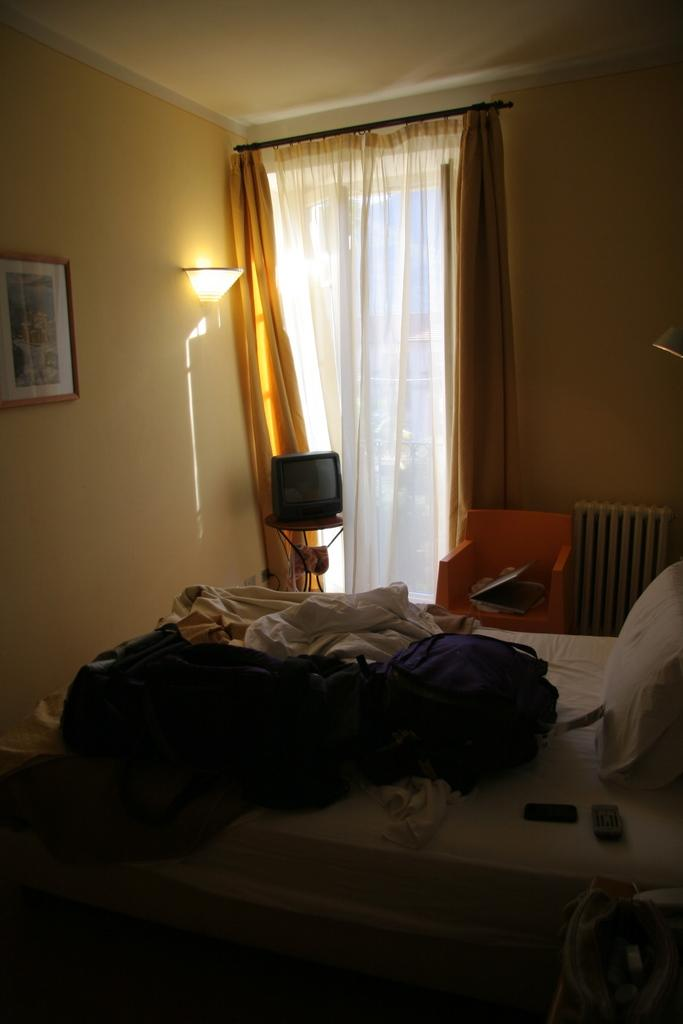What type of space is shown in the image? The image depicts an inside view of a room. What furniture is present in the room? There is a bed and a chair in the room. What electronic device is in the room? There is a television in the room. What window treatment is present in the room? There are curtains in the room. What lighting is present in the room? There are lights in the room. What decorative item is on the wall in the room? There is a frame on the wall in the room. What type of mouth can be seen on the passenger in the room? There is no passenger present in the room; it is an inside view of a room with furniture and other items. 